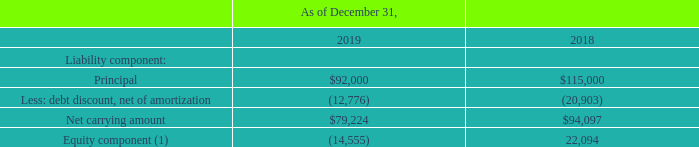The 2022 Notes consist of the following (in thousands):
(1) Recorded in the consolidated balance sheet within additional paid-in capital, net of $0.8 million transaction costs in equity. December 31, 2019 also includes $36.7 million market premium representing the excess of the total consideration delivered over the fair value of the liability recognized related to the $23.0 million principal balance repurchase of the 2022 Notes.
What is the net carrying amount in 2019?
Answer scale should be: thousand. $79,224. How much was the market premium at December 31, 2019? $36.7 million. What does market premium of $36.7 million represent? The excess of the total consideration delivered over the fair value of the liability recognized related to the $23.0 million principal balance repurchase of the 2022 notes. What is the change in Principal from December 31, 2019 to December 31, 2018?
Answer scale should be: thousand. 92,000-115,000
Answer: -23000. What is the change in the debt discount, net of amortization from December 31, 2019 to December 31, 2018?
Answer scale should be: thousand. 12,776-20,903
Answer: -8127. What is the change in Net carrying amount from December 31, 2019 to December 31, 2018?
Answer scale should be: thousand. 79,224-94,097
Answer: -14873. 